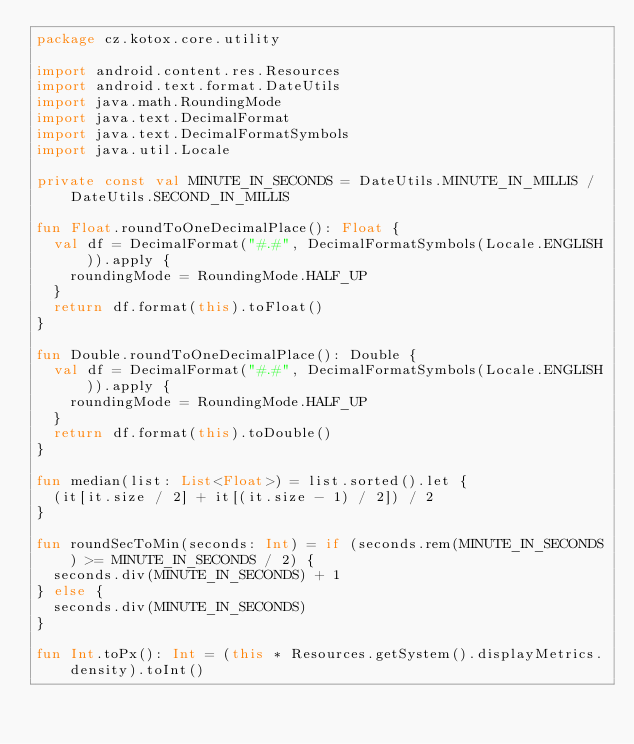<code> <loc_0><loc_0><loc_500><loc_500><_Kotlin_>package cz.kotox.core.utility

import android.content.res.Resources
import android.text.format.DateUtils
import java.math.RoundingMode
import java.text.DecimalFormat
import java.text.DecimalFormatSymbols
import java.util.Locale

private const val MINUTE_IN_SECONDS = DateUtils.MINUTE_IN_MILLIS / DateUtils.SECOND_IN_MILLIS

fun Float.roundToOneDecimalPlace(): Float {
	val df = DecimalFormat("#.#", DecimalFormatSymbols(Locale.ENGLISH)).apply {
		roundingMode = RoundingMode.HALF_UP
	}
	return df.format(this).toFloat()
}

fun Double.roundToOneDecimalPlace(): Double {
	val df = DecimalFormat("#.#", DecimalFormatSymbols(Locale.ENGLISH)).apply {
		roundingMode = RoundingMode.HALF_UP
	}
	return df.format(this).toDouble()
}

fun median(list: List<Float>) = list.sorted().let {
	(it[it.size / 2] + it[(it.size - 1) / 2]) / 2
}

fun roundSecToMin(seconds: Int) = if (seconds.rem(MINUTE_IN_SECONDS) >= MINUTE_IN_SECONDS / 2) {
	seconds.div(MINUTE_IN_SECONDS) + 1
} else {
	seconds.div(MINUTE_IN_SECONDS)
}

fun Int.toPx(): Int = (this * Resources.getSystem().displayMetrics.density).toInt()</code> 